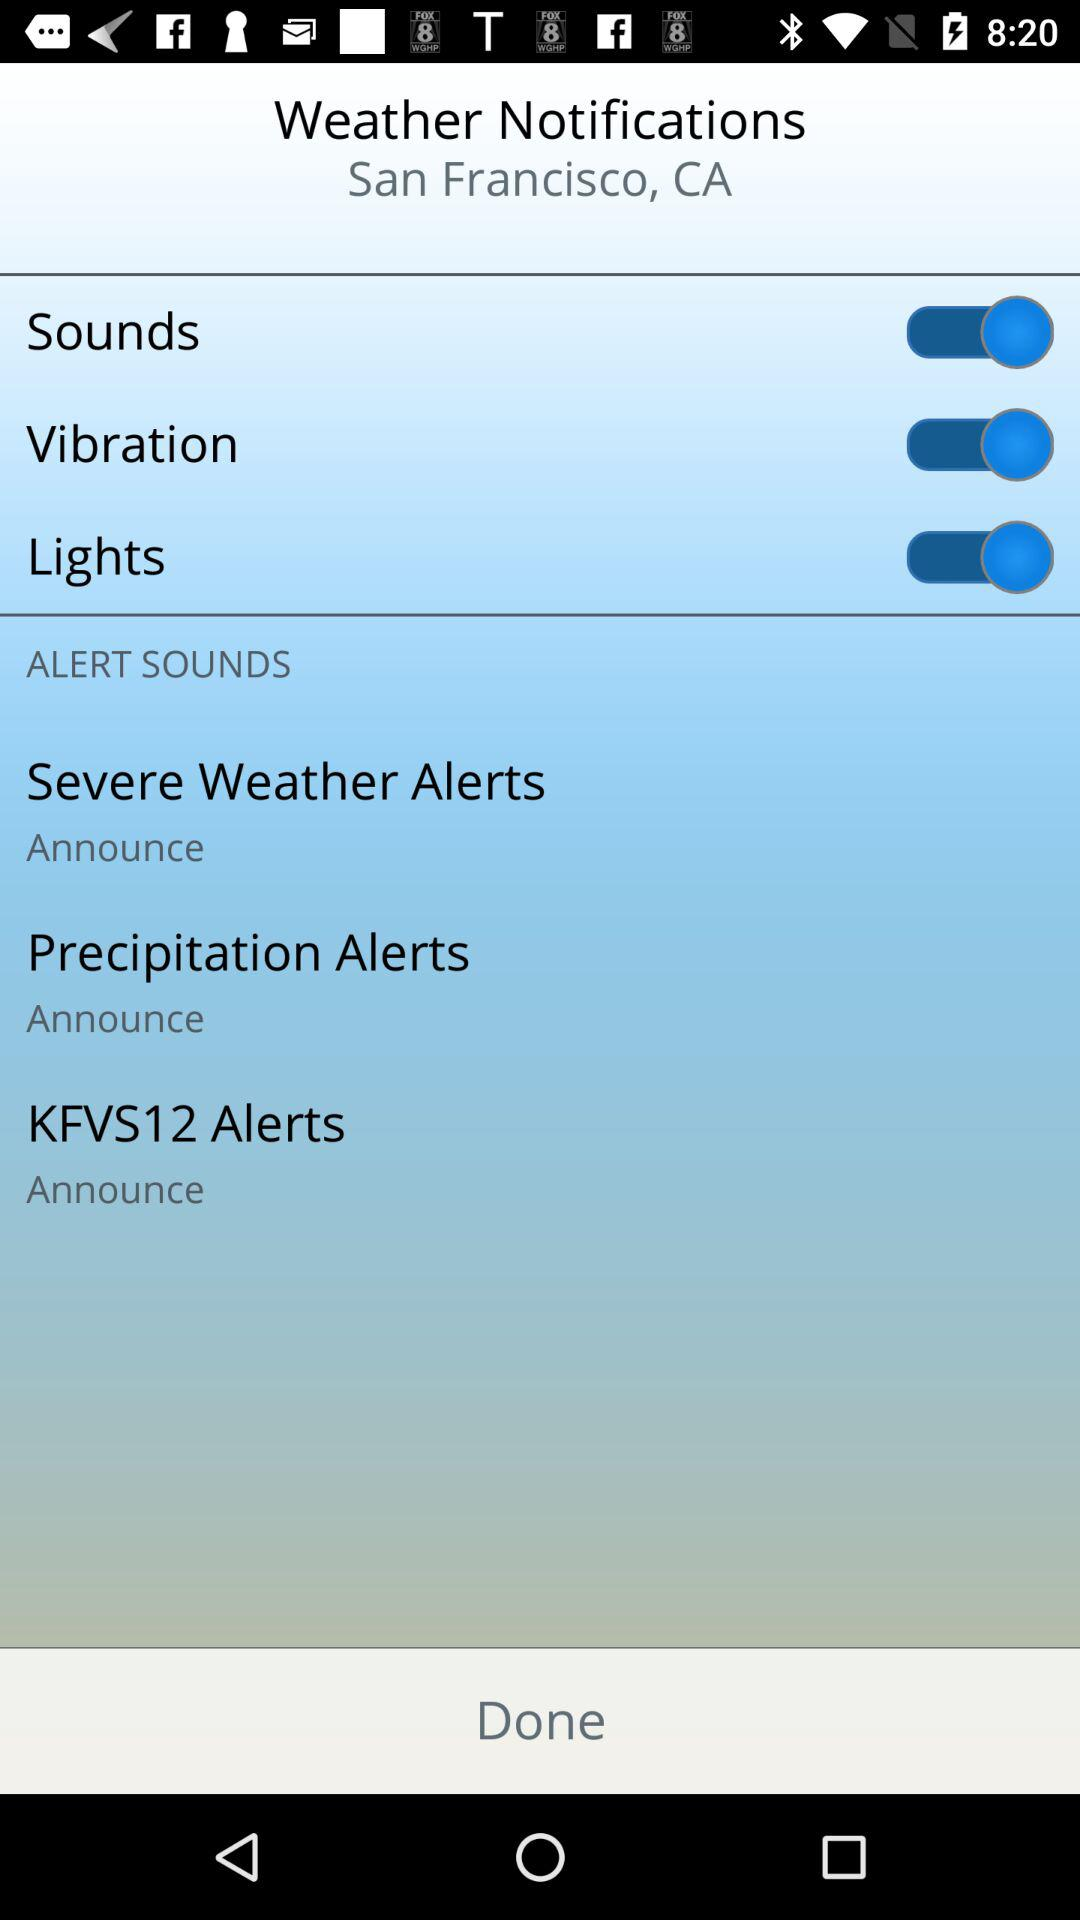What is the status of "Lights"? The status is "on". 